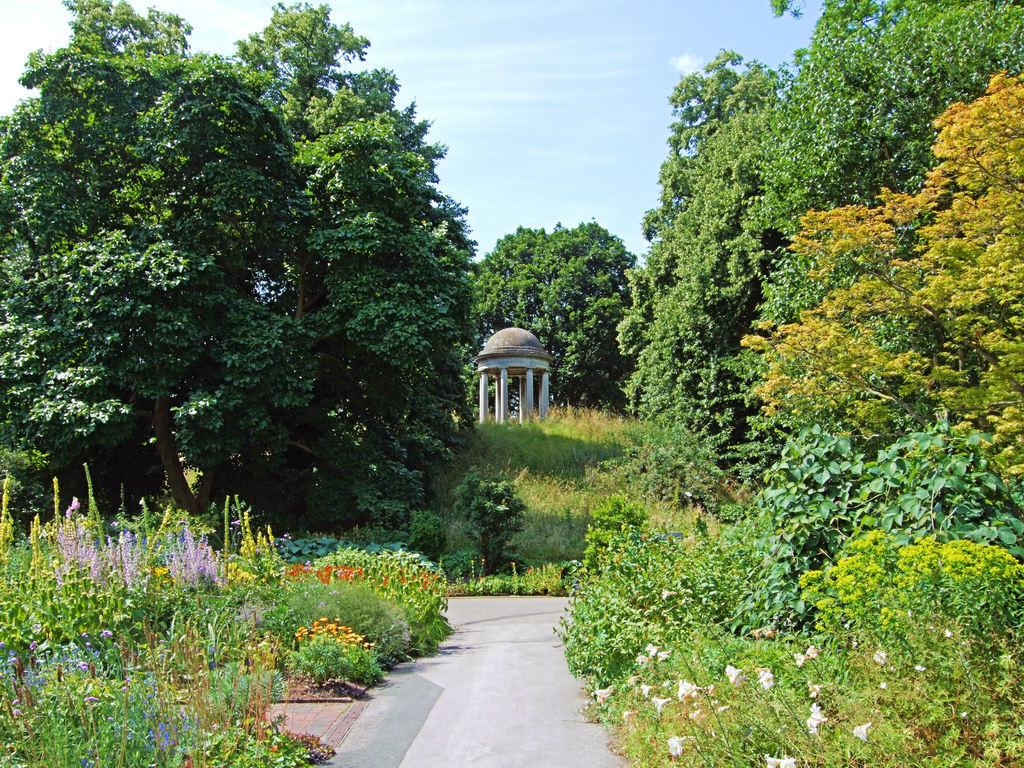What type of structures can be seen in the image? There are pillars in the image. What type of natural elements are present in the image? There are trees, plants, flowers, grass, and clouds visible in the image. What type of man-made structures can be seen in the image? There are roads in the image. What part of the natural environment is visible in the image? The sky is visible in the image. What type of body is depicted in the image? There is no body depicted in the image; it features pillars, trees, plants, flowers, grass, roads, sky, and clouds. What historical event is being commemorated in the image? There is no historical event being commemorated in the image; it is a scene of natural and man-made elements. 